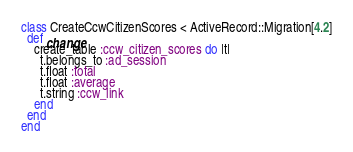Convert code to text. <code><loc_0><loc_0><loc_500><loc_500><_Ruby_>class CreateCcwCitizenScores < ActiveRecord::Migration[4.2]
  def change
    create_table :ccw_citizen_scores do |t|
      t.belongs_to :ad_session
      t.float :total
      t.float :average
      t.string :ccw_link
    end
  end
end
</code> 